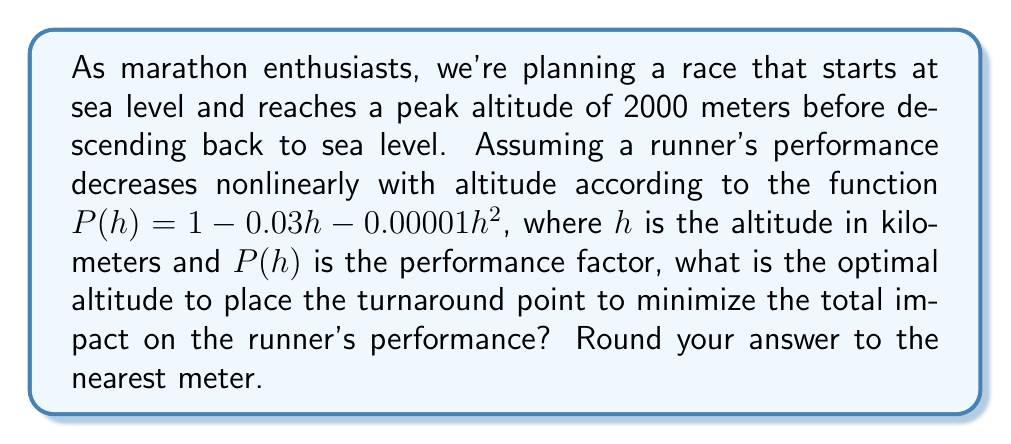What is the answer to this math problem? To solve this problem, we'll use nonlinear optimization techniques:

1) First, let's define our objective function. We want to minimize the total impact on performance, which is the integral of $1 - P(h)$ over the course of the race.

2) The race profile is symmetric, so we can focus on just the uphill portion and double it. Let $x$ be the turnaround point altitude in km. Our objective function is:

   $$f(x) = 2 \int_0^x (1 - P(h)) dh = 2 \int_0^x (0.03h + 0.00001h^2) dh$$

3) Evaluating the integral:

   $$f(x) = 2 [0.015h^2 + \frac{1}{3} \cdot 10^{-5}h^3]_0^x = 0.03x^2 + \frac{2}{3} \cdot 10^{-5}x^3$$

4) To find the minimum, we differentiate and set to zero:

   $$f'(x) = 0.06x + 2 \cdot 10^{-5}x^2 = 0$$

5) Factoring out $x$:

   $$x(0.06 + 2 \cdot 10^{-5}x) = 0$$

6) Solving for $x$:

   $$x = 0$$ or $$0.06 + 2 \cdot 10^{-5}x = 0$$
   
   $$x = -3000$$

7) The negative solution is not physically meaningful, so we check the endpoints:

   At $x = 0$: $f(0) = 0$
   At $x = 2$: $f(2) = 0.12 + \frac{16}{3} \cdot 10^{-5} \approx 0.1205$

8) The minimum occurs at $x = 0$, meaning the optimal turnaround point is at sea level.
Answer: 0 meters 